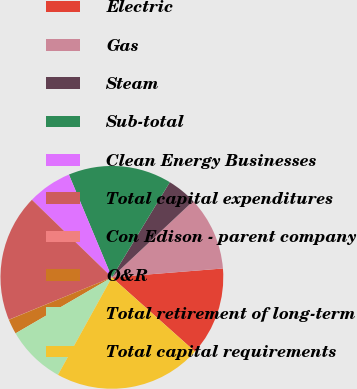Convert chart. <chart><loc_0><loc_0><loc_500><loc_500><pie_chart><fcel>Electric<fcel>Gas<fcel>Steam<fcel>Sub-total<fcel>Clean Energy Businesses<fcel>Total capital expenditures<fcel>Con Edison - parent company<fcel>O&R<fcel>Total retirement of long-term<fcel>Total capital requirements<nl><fcel>12.87%<fcel>10.73%<fcel>4.3%<fcel>15.01%<fcel>6.44%<fcel>18.46%<fcel>0.02%<fcel>2.16%<fcel>8.58%<fcel>21.44%<nl></chart> 